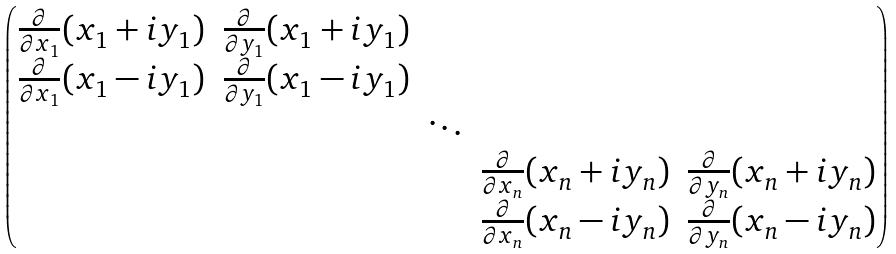Convert formula to latex. <formula><loc_0><loc_0><loc_500><loc_500>\begin{pmatrix} \frac { \partial } { \partial x _ { 1 } } ( x _ { 1 } + i y _ { 1 } ) & \frac { \partial } { \partial y _ { 1 } } ( x _ { 1 } + i y _ { 1 } ) & & & \\ \frac { \partial } { \partial x _ { 1 } } ( x _ { 1 } - i y _ { 1 } ) & \frac { \partial } { \partial y _ { 1 } } ( x _ { 1 } - i y _ { 1 } ) & & & \\ & & \ddots & & \\ & & & \frac { \partial } { \partial x _ { n } } ( x _ { n } + i y _ { n } ) & \frac { \partial } { \partial y _ { n } } ( x _ { n } + i y _ { n } ) \\ & & & \frac { \partial } { \partial x _ { n } } ( x _ { n } - i y _ { n } ) & \frac { \partial } { \partial y _ { n } } ( x _ { n } - i y _ { n } ) \end{pmatrix}</formula> 